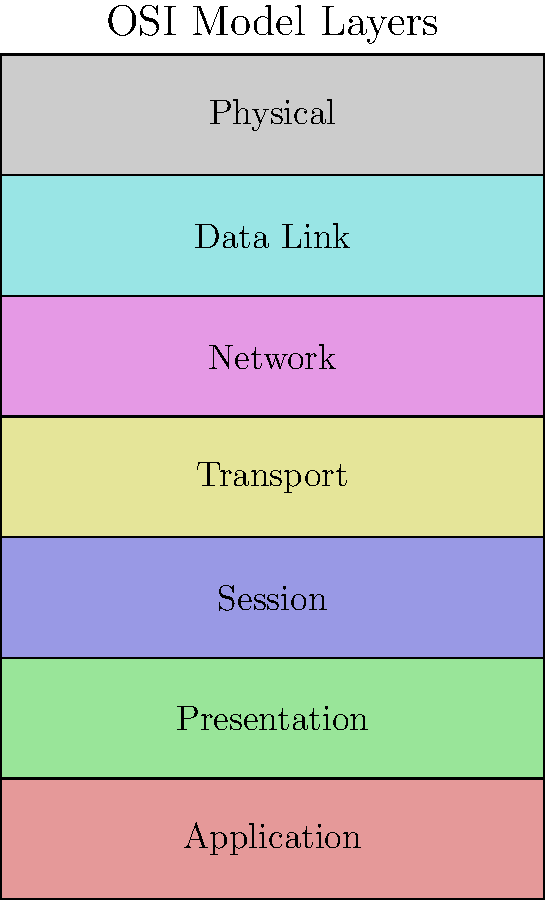In the OSI model stack diagram, which layer is responsible for end-to-end communication and error recovery between applications running on different hosts? To answer this question, let's analyze the OSI model layers from top to bottom:

1. Application Layer (Layer 7): Provides network services directly to end-users or applications.
2. Presentation Layer (Layer 6): Handles data formatting, encryption, and compression.
3. Session Layer (Layer 5): Manages sessions between applications.
4. Transport Layer (Layer 4): This is the key layer for our question. It is responsible for:
   - End-to-end communication between applications on different hosts
   - Error recovery and flow control
   - Segmentation of data and reassembly
   - Establishing, maintaining, and terminating connections
5. Network Layer (Layer 3): Handles routing and addressing of data packets.
6. Data Link Layer (Layer 2): Provides node-to-node data transfer and error detection.
7. Physical Layer (Layer 1): Deals with the physical transmission of data bits.

The Transport Layer (Layer 4) is specifically designed to ensure reliable end-to-end communication between applications, regardless of the underlying network infrastructure. It uses protocols like TCP (Transmission Control Protocol) to provide error recovery, flow control, and ordered delivery of data segments.
Answer: Transport Layer 